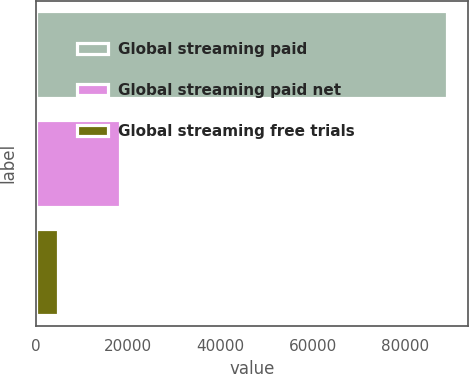<chart> <loc_0><loc_0><loc_500><loc_500><bar_chart><fcel>Global streaming paid<fcel>Global streaming paid net<fcel>Global streaming free trials<nl><fcel>89090<fcel>18251<fcel>4706<nl></chart> 